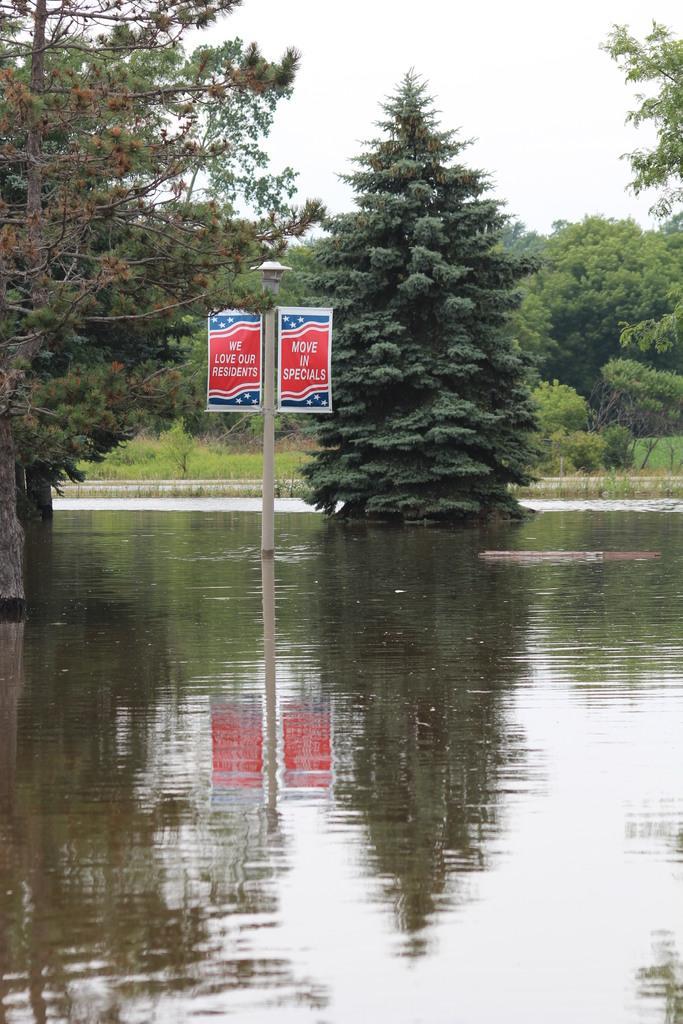How would you summarize this image in a sentence or two? As we can see in the image there are trees, grass, poster and water. On the top there is a sky. 